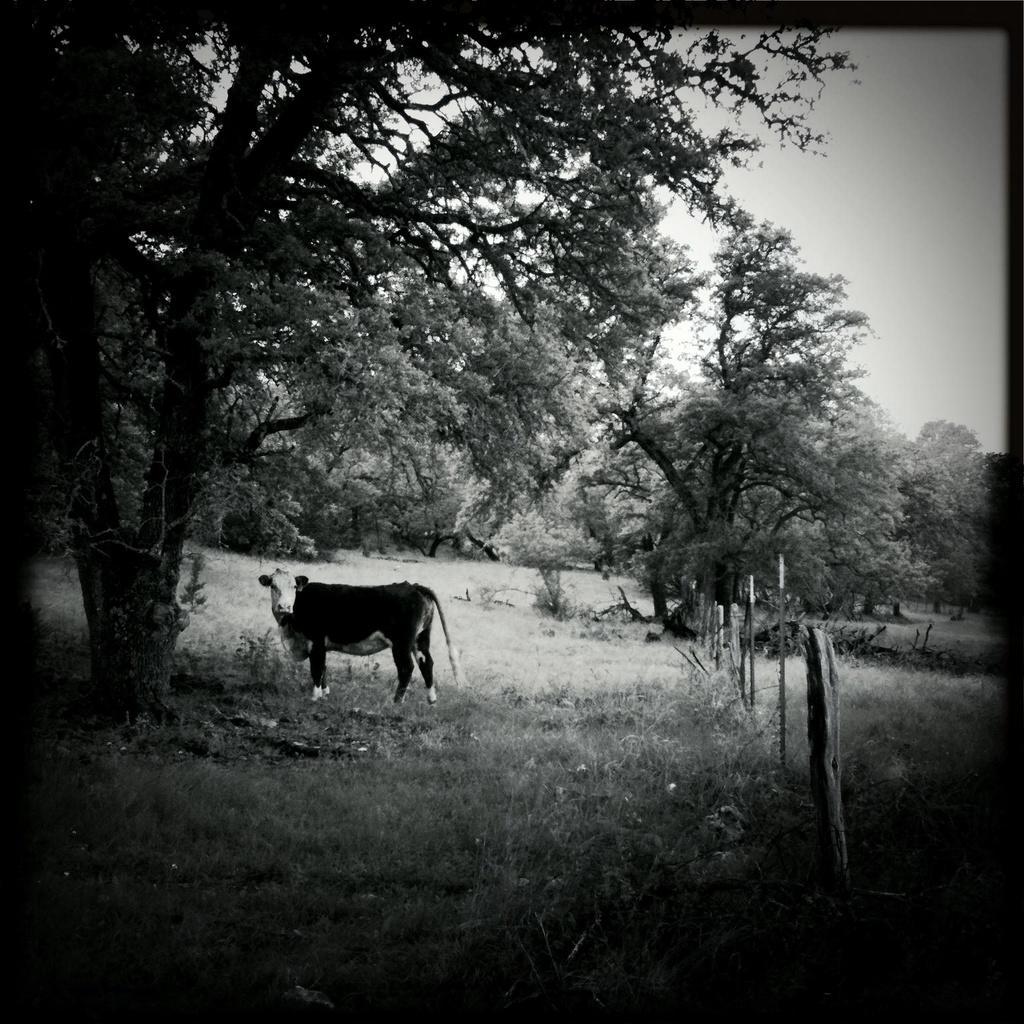Could you give a brief overview of what you see in this image? In the center of the image there is an animal and there are trees. On the right there is a fence. In the background there is sky. 